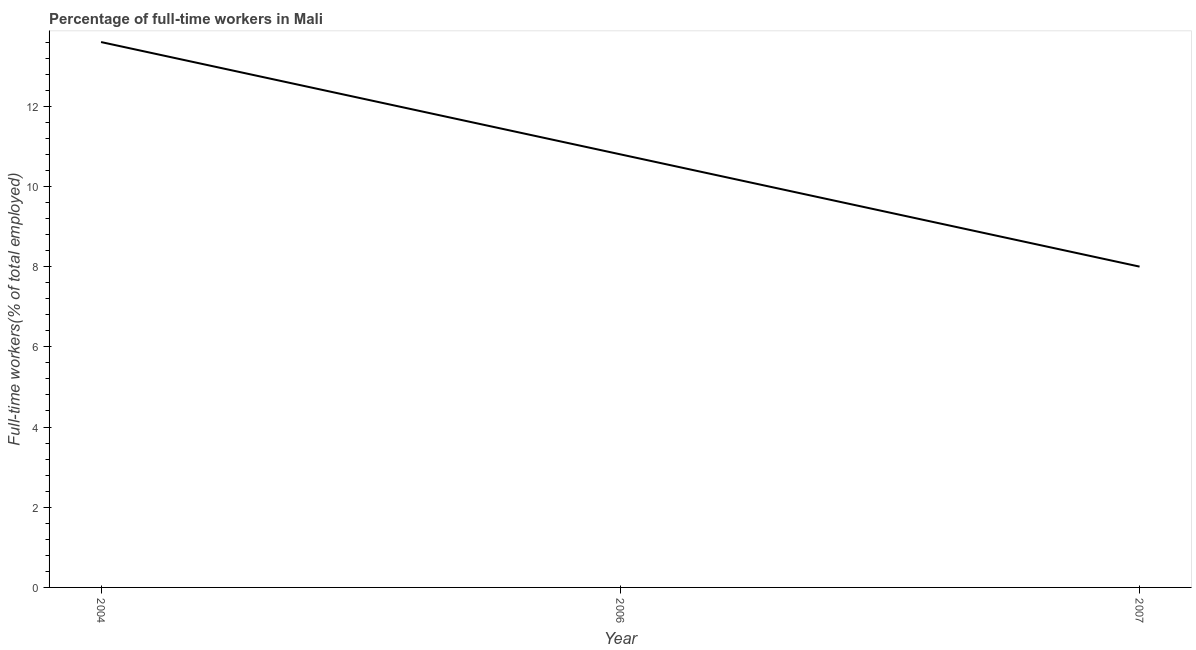Across all years, what is the maximum percentage of full-time workers?
Your response must be concise. 13.6. Across all years, what is the minimum percentage of full-time workers?
Ensure brevity in your answer.  8. In which year was the percentage of full-time workers minimum?
Your response must be concise. 2007. What is the sum of the percentage of full-time workers?
Ensure brevity in your answer.  32.4. What is the difference between the percentage of full-time workers in 2006 and 2007?
Your response must be concise. 2.8. What is the average percentage of full-time workers per year?
Keep it short and to the point. 10.8. What is the median percentage of full-time workers?
Ensure brevity in your answer.  10.8. In how many years, is the percentage of full-time workers greater than 7.6 %?
Make the answer very short. 3. Do a majority of the years between 2006 and 2004 (inclusive) have percentage of full-time workers greater than 5.2 %?
Provide a short and direct response. No. What is the ratio of the percentage of full-time workers in 2006 to that in 2007?
Provide a short and direct response. 1.35. What is the difference between the highest and the second highest percentage of full-time workers?
Give a very brief answer. 2.8. What is the difference between the highest and the lowest percentage of full-time workers?
Offer a terse response. 5.6. Are the values on the major ticks of Y-axis written in scientific E-notation?
Your answer should be compact. No. Does the graph contain any zero values?
Provide a short and direct response. No. What is the title of the graph?
Your response must be concise. Percentage of full-time workers in Mali. What is the label or title of the X-axis?
Keep it short and to the point. Year. What is the label or title of the Y-axis?
Your answer should be very brief. Full-time workers(% of total employed). What is the Full-time workers(% of total employed) in 2004?
Make the answer very short. 13.6. What is the Full-time workers(% of total employed) of 2006?
Your answer should be very brief. 10.8. What is the difference between the Full-time workers(% of total employed) in 2006 and 2007?
Give a very brief answer. 2.8. What is the ratio of the Full-time workers(% of total employed) in 2004 to that in 2006?
Your answer should be compact. 1.26. What is the ratio of the Full-time workers(% of total employed) in 2004 to that in 2007?
Make the answer very short. 1.7. What is the ratio of the Full-time workers(% of total employed) in 2006 to that in 2007?
Provide a succinct answer. 1.35. 